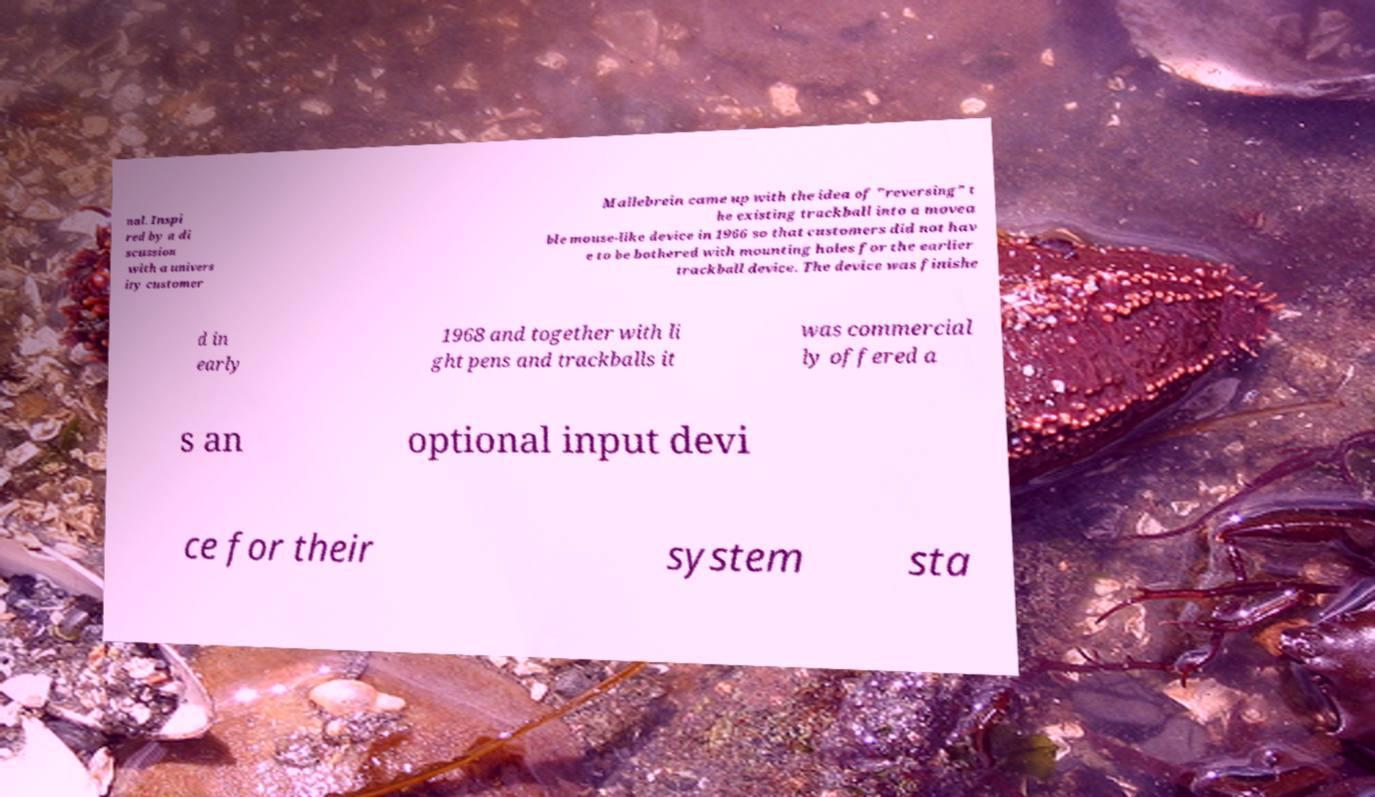Can you accurately transcribe the text from the provided image for me? nal. Inspi red by a di scussion with a univers ity customer Mallebrein came up with the idea of "reversing" t he existing trackball into a movea ble mouse-like device in 1966 so that customers did not hav e to be bothered with mounting holes for the earlier trackball device. The device was finishe d in early 1968 and together with li ght pens and trackballs it was commercial ly offered a s an optional input devi ce for their system sta 